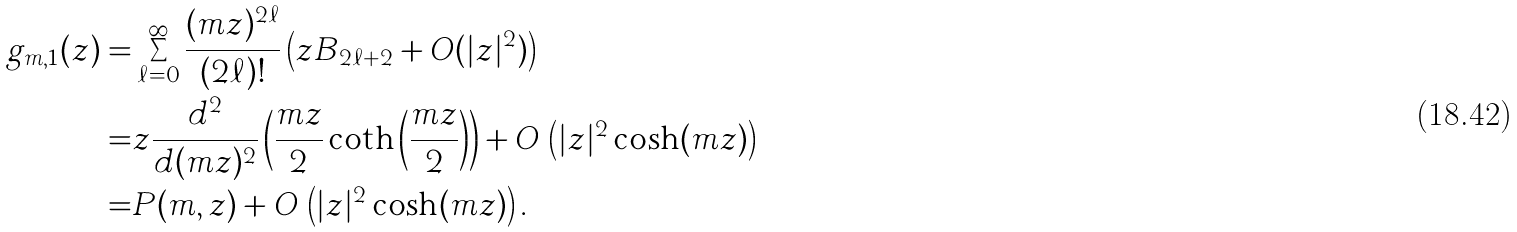Convert formula to latex. <formula><loc_0><loc_0><loc_500><loc_500>g _ { m , 1 } ( z ) = & \sum _ { \ell = 0 } ^ { \infty } \frac { ( m z ) ^ { 2 \ell } } { ( 2 \ell ) ! } \left ( z B _ { 2 \ell + 2 } + O ( | z | ^ { 2 } ) \right ) \\ = & z \frac { d ^ { 2 } } { d ( m z ) ^ { 2 } } \left ( \frac { m z } { 2 } \coth \left ( \frac { m z } { 2 } \right ) \right ) + O \, \left ( | z | ^ { 2 } \cosh ( m z ) \right ) \\ = & P ( m , z ) + O \, \left ( | z | ^ { 2 } \cosh ( m z ) \right ) .</formula> 